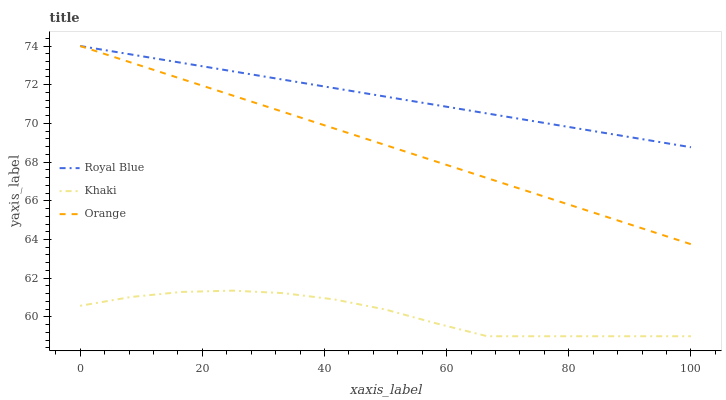Does Khaki have the minimum area under the curve?
Answer yes or no. Yes. Does Royal Blue have the maximum area under the curve?
Answer yes or no. Yes. Does Royal Blue have the minimum area under the curve?
Answer yes or no. No. Does Khaki have the maximum area under the curve?
Answer yes or no. No. Is Royal Blue the smoothest?
Answer yes or no. Yes. Is Khaki the roughest?
Answer yes or no. Yes. Is Khaki the smoothest?
Answer yes or no. No. Is Royal Blue the roughest?
Answer yes or no. No. Does Khaki have the lowest value?
Answer yes or no. Yes. Does Royal Blue have the lowest value?
Answer yes or no. No. Does Royal Blue have the highest value?
Answer yes or no. Yes. Does Khaki have the highest value?
Answer yes or no. No. Is Khaki less than Orange?
Answer yes or no. Yes. Is Royal Blue greater than Khaki?
Answer yes or no. Yes. Does Orange intersect Royal Blue?
Answer yes or no. Yes. Is Orange less than Royal Blue?
Answer yes or no. No. Is Orange greater than Royal Blue?
Answer yes or no. No. Does Khaki intersect Orange?
Answer yes or no. No. 